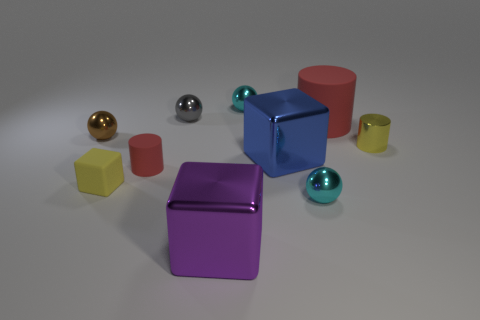Do the large red thing and the small cyan sphere that is in front of the big rubber thing have the same material?
Offer a terse response. No. Is the color of the shiny ball that is in front of the small yellow matte block the same as the metallic cylinder?
Your answer should be compact. No. The tiny object that is in front of the yellow shiny thing and behind the tiny rubber cube is made of what material?
Your answer should be very brief. Rubber. What size is the blue object?
Provide a short and direct response. Large. There is a metallic cylinder; is its color the same as the small rubber cube in front of the tiny metallic cylinder?
Keep it short and to the point. Yes. Is the size of the yellow thing left of the small gray ball the same as the red rubber object that is on the left side of the large purple block?
Your response must be concise. Yes. What color is the metal thing that is right of the large matte cylinder?
Offer a terse response. Yellow. Is the number of tiny brown objects in front of the small red rubber thing less than the number of blue metal things?
Your answer should be compact. Yes. Do the yellow cube and the tiny red thing have the same material?
Your response must be concise. Yes. The purple thing that is the same shape as the tiny yellow matte thing is what size?
Provide a succinct answer. Large. 